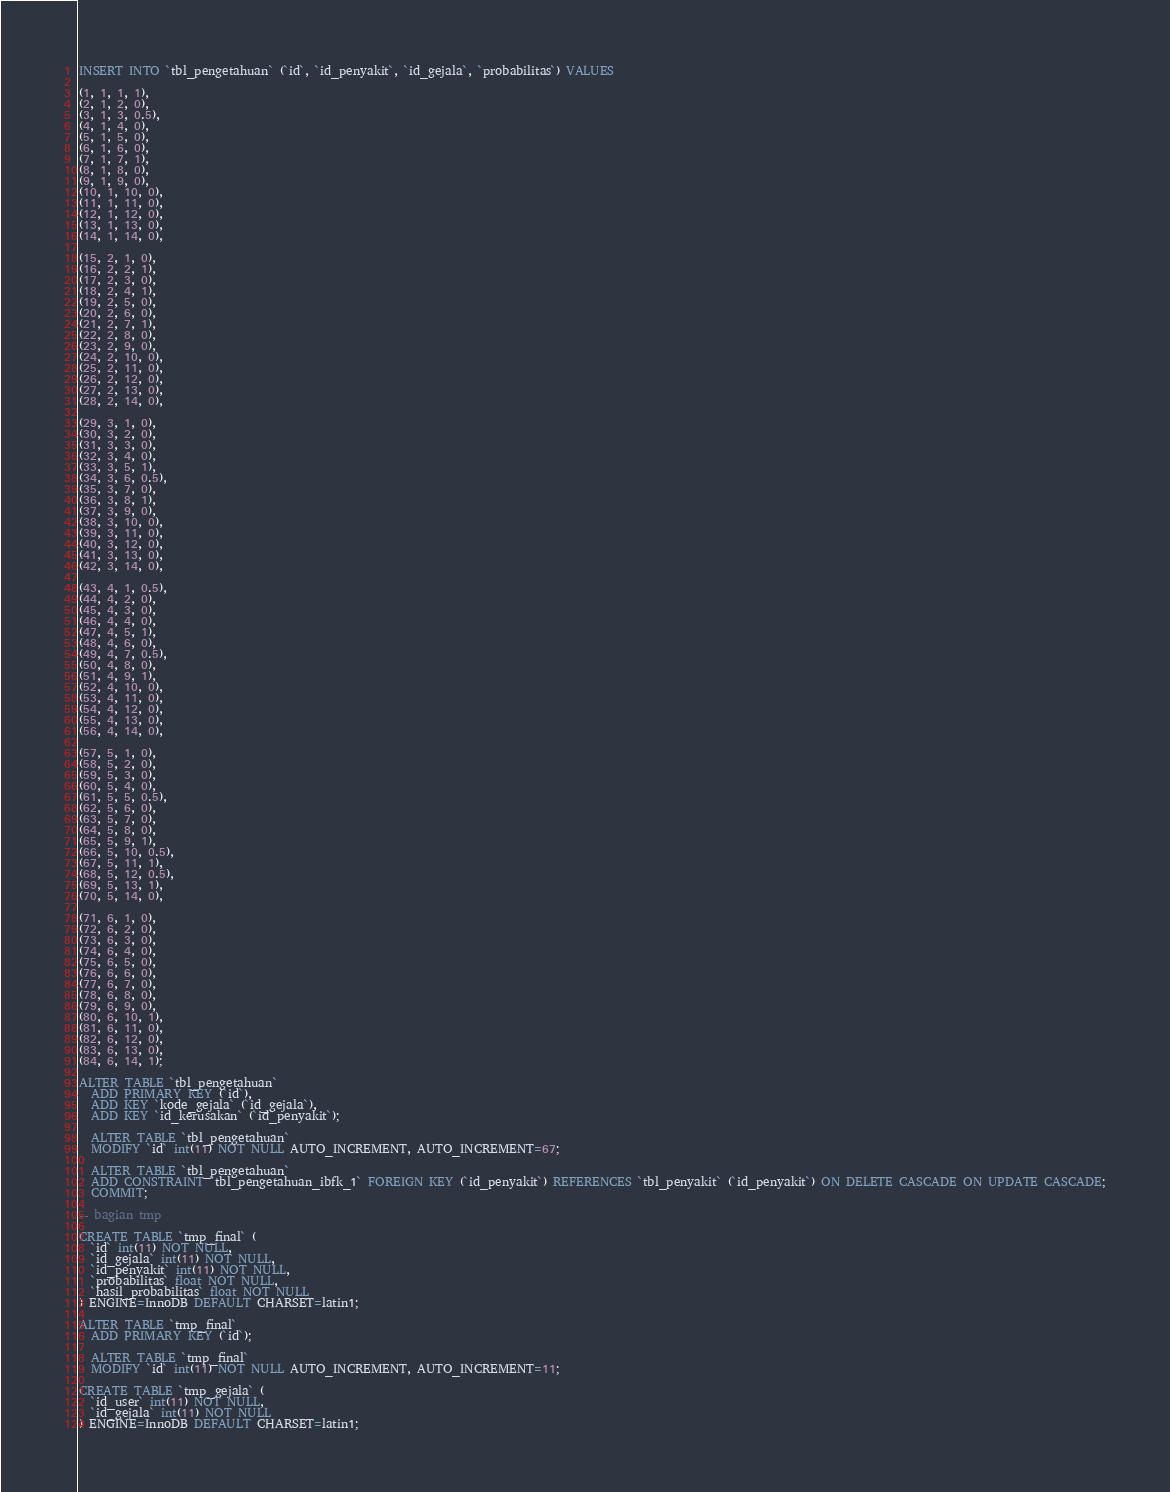Convert code to text. <code><loc_0><loc_0><loc_500><loc_500><_SQL_>
INSERT INTO `tbl_pengetahuan` (`id`, `id_penyakit`, `id_gejala`, `probabilitas`) VALUES

(1, 1, 1, 1),
(2, 1, 2, 0),
(3, 1, 3, 0.5),
(4, 1, 4, 0),
(5, 1, 5, 0),
(6, 1, 6, 0),
(7, 1, 7, 1),
(8, 1, 8, 0),
(9, 1, 9, 0),
(10, 1, 10, 0),
(11, 1, 11, 0),
(12, 1, 12, 0),
(13, 1, 13, 0),
(14, 1, 14, 0),

(15, 2, 1, 0),
(16, 2, 2, 1),
(17, 2, 3, 0),
(18, 2, 4, 1),
(19, 2, 5, 0),
(20, 2, 6, 0),
(21, 2, 7, 1),
(22, 2, 8, 0),
(23, 2, 9, 0),
(24, 2, 10, 0),
(25, 2, 11, 0),
(26, 2, 12, 0),
(27, 2, 13, 0),
(28, 2, 14, 0),

(29, 3, 1, 0),
(30, 3, 2, 0),
(31, 3, 3, 0),
(32, 3, 4, 0),
(33, 3, 5, 1),
(34, 3, 6, 0.5),
(35, 3, 7, 0),
(36, 3, 8, 1),
(37, 3, 9, 0),
(38, 3, 10, 0),
(39, 3, 11, 0),
(40, 3, 12, 0),
(41, 3, 13, 0),
(42, 3, 14, 0),

(43, 4, 1, 0.5),
(44, 4, 2, 0),
(45, 4, 3, 0),
(46, 4, 4, 0),
(47, 4, 5, 1),
(48, 4, 6, 0),
(49, 4, 7, 0.5),
(50, 4, 8, 0),
(51, 4, 9, 1),
(52, 4, 10, 0),
(53, 4, 11, 0),
(54, 4, 12, 0),
(55, 4, 13, 0),
(56, 4, 14, 0),

(57, 5, 1, 0),
(58, 5, 2, 0),
(59, 5, 3, 0),
(60, 5, 4, 0),
(61, 5, 5, 0.5),
(62, 5, 6, 0),
(63, 5, 7, 0),
(64, 5, 8, 0),
(65, 5, 9, 1),
(66, 5, 10, 0.5),
(67, 5, 11, 1),
(68, 5, 12, 0.5),
(69, 5, 13, 1),
(70, 5, 14, 0),

(71, 6, 1, 0),
(72, 6, 2, 0),
(73, 6, 3, 0),
(74, 6, 4, 0),
(75, 6, 5, 0),
(76, 6, 6, 0),
(77, 6, 7, 0),
(78, 6, 8, 0),
(79, 6, 9, 0),
(80, 6, 10, 1),
(81, 6, 11, 0),
(82, 6, 12, 0),
(83, 6, 13, 0),
(84, 6, 14, 1);

ALTER TABLE `tbl_pengetahuan`
  ADD PRIMARY KEY (`id`),
  ADD KEY `kode_gejala` (`id_gejala`),
  ADD KEY `id_kerusakan` (`id_penyakit`);

  ALTER TABLE `tbl_pengetahuan`
  MODIFY `id` int(11) NOT NULL AUTO_INCREMENT, AUTO_INCREMENT=67;

  ALTER TABLE `tbl_pengetahuan`
  ADD CONSTRAINT `tbl_pengetahuan_ibfk_1` FOREIGN KEY (`id_penyakit`) REFERENCES `tbl_penyakit` (`id_penyakit`) ON DELETE CASCADE ON UPDATE CASCADE;
  COMMIT;

-- bagian tmp

CREATE TABLE `tmp_final` (
  `id` int(11) NOT NULL,
  `id_gejala` int(11) NOT NULL,
  `id_penyakit` int(11) NOT NULL,
  `probabilitas` float NOT NULL,
  `hasil_probabilitas` float NOT NULL
) ENGINE=InnoDB DEFAULT CHARSET=latin1;

ALTER TABLE `tmp_final`
  ADD PRIMARY KEY (`id`);

  ALTER TABLE `tmp_final`
  MODIFY `id` int(11) NOT NULL AUTO_INCREMENT, AUTO_INCREMENT=11;

CREATE TABLE `tmp_gejala` (
  `id_user` int(11) NOT NULL,
  `id_gejala` int(11) NOT NULL
) ENGINE=InnoDB DEFAULT CHARSET=latin1;</code> 